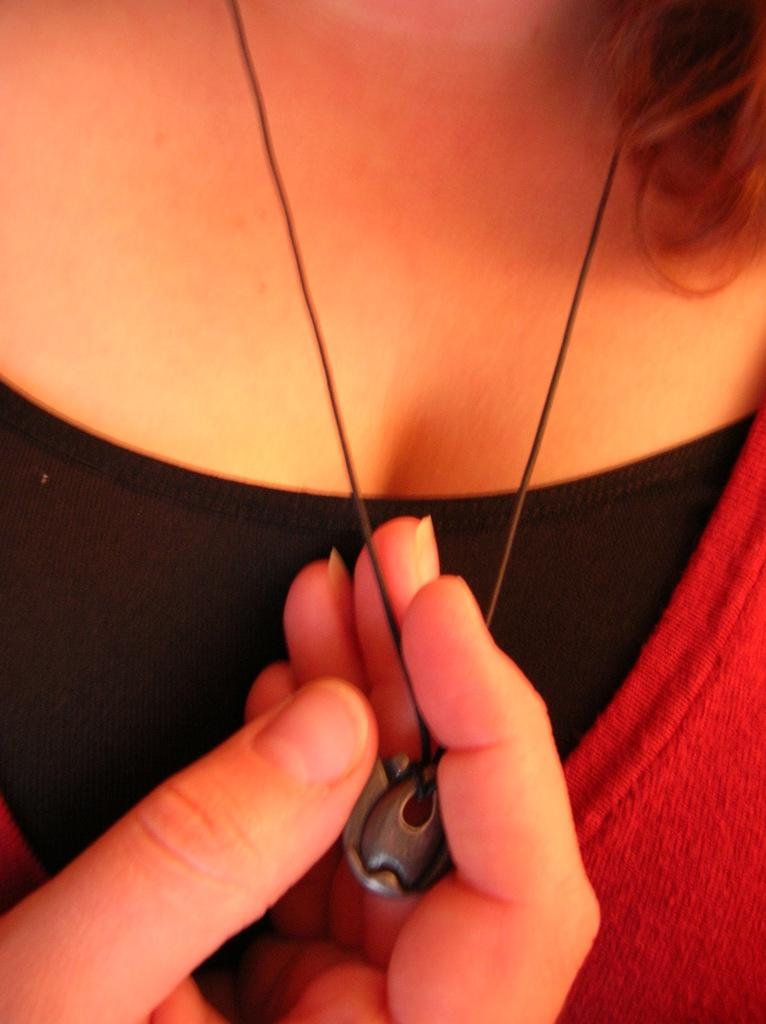What is the main subject of the image? There is a person in the image. What is the person holding in the image? The person is holding a chain in the image. What is attached to the chain that the person is holding? The chain has a pendant attached to it. What type of vessel can be seen sailing in the background of the image? There is no vessel or background visible in the image; it only features a person holding a chain with a pendant attached to it. 